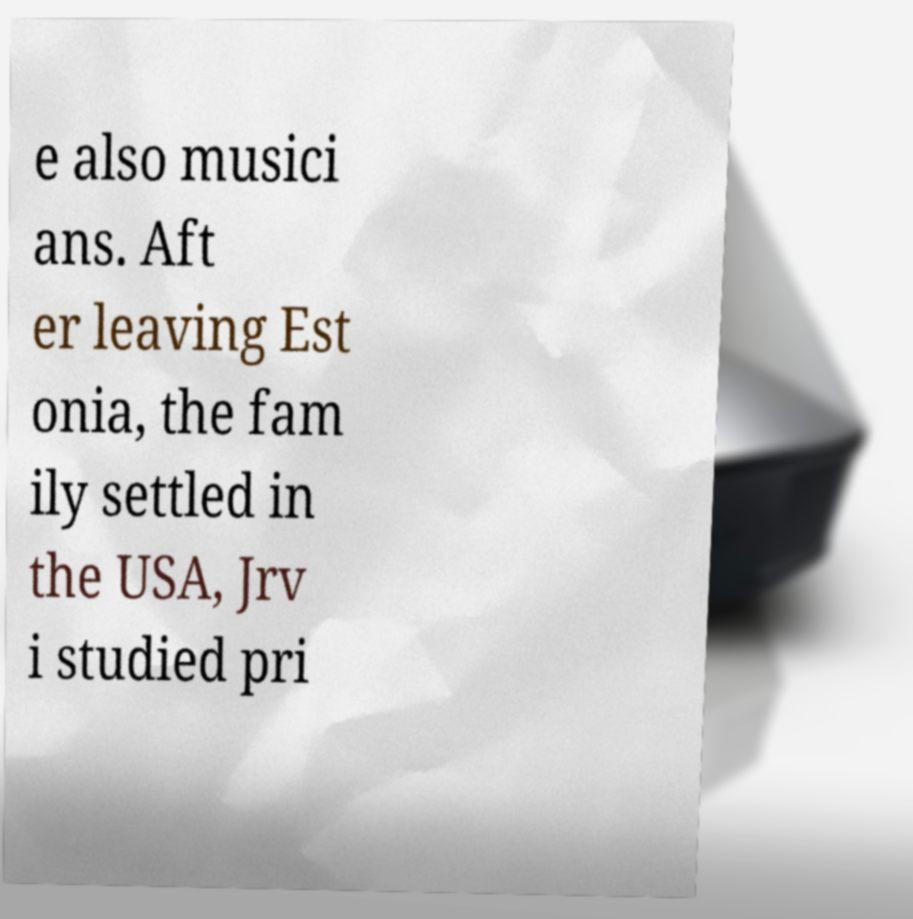Could you extract and type out the text from this image? e also musici ans. Aft er leaving Est onia, the fam ily settled in the USA, Jrv i studied pri 